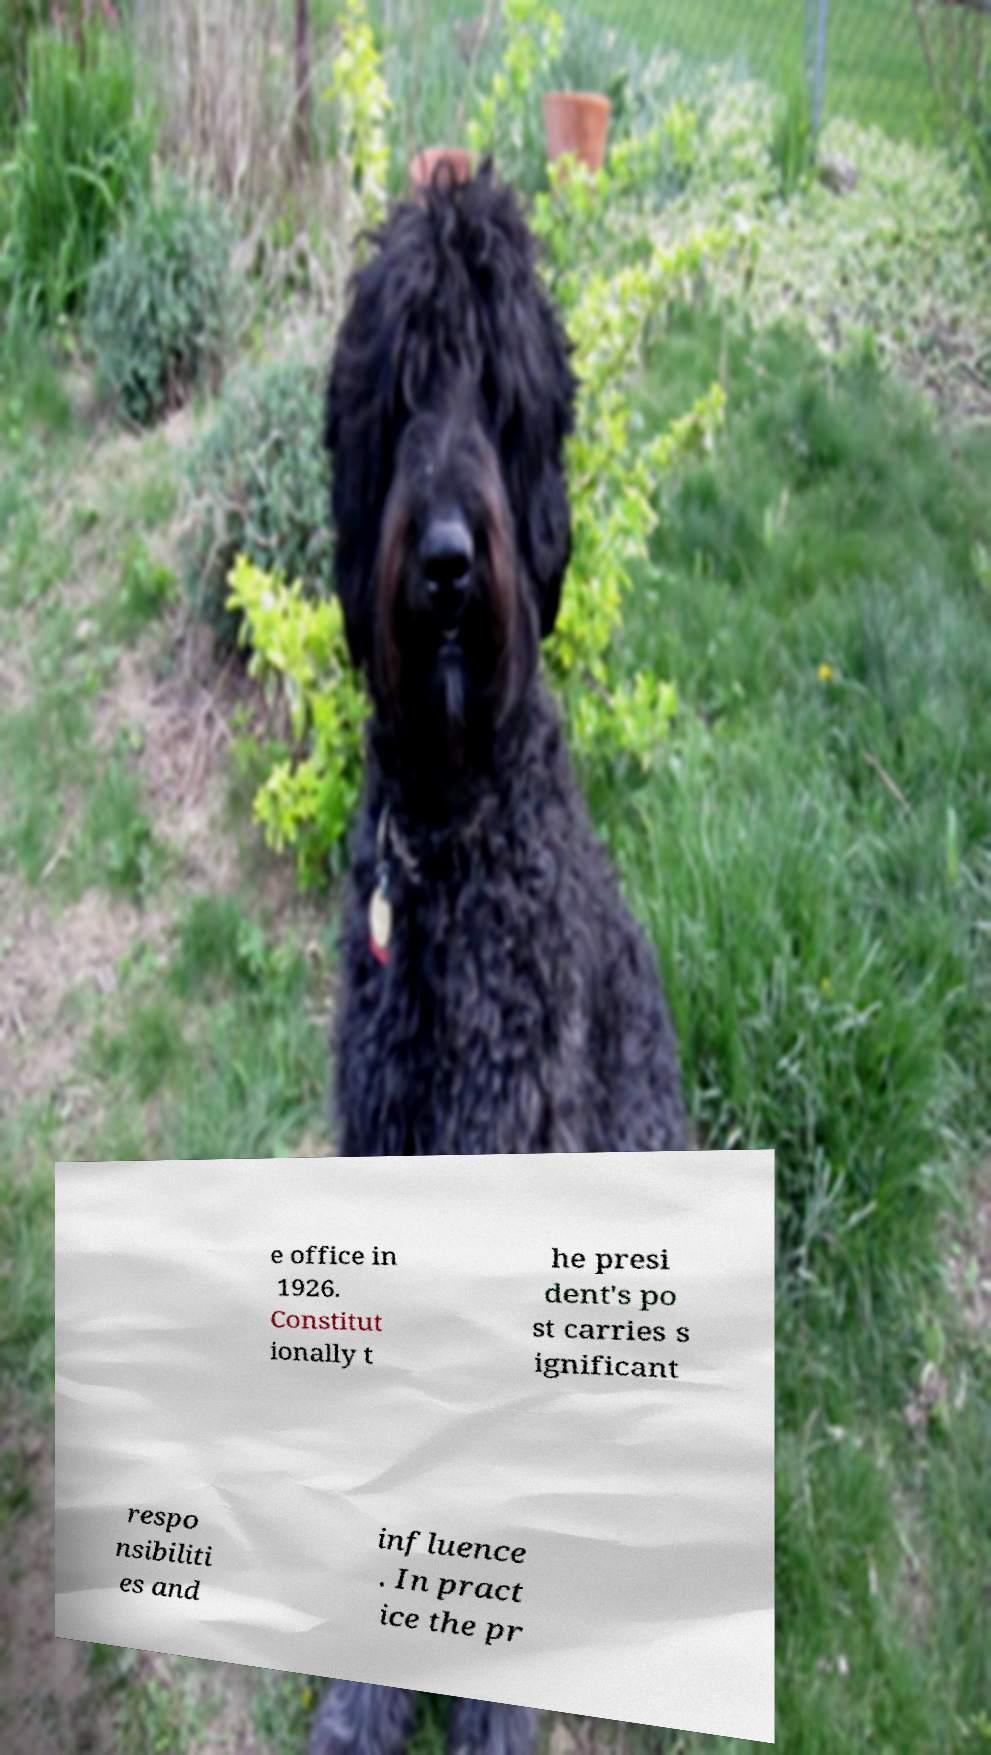Could you assist in decoding the text presented in this image and type it out clearly? e office in 1926. Constitut ionally t he presi dent's po st carries s ignificant respo nsibiliti es and influence . In pract ice the pr 